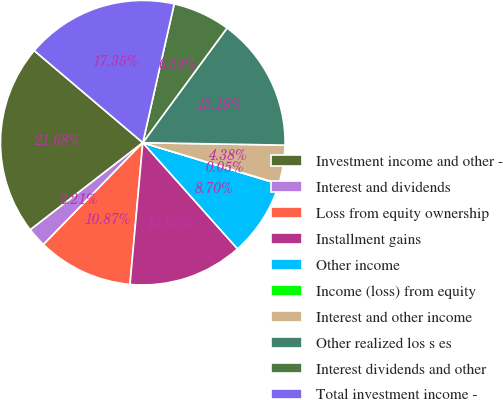<chart> <loc_0><loc_0><loc_500><loc_500><pie_chart><fcel>Investment income and other -<fcel>Interest and dividends<fcel>Loss from equity ownership<fcel>Installment gains<fcel>Other income<fcel>Income (loss) from equity<fcel>Interest and other income<fcel>Other realized los s es<fcel>Interest dividends and other<fcel>Total investment income -<nl><fcel>21.68%<fcel>2.21%<fcel>10.87%<fcel>13.03%<fcel>8.7%<fcel>0.05%<fcel>4.38%<fcel>15.19%<fcel>6.54%<fcel>17.35%<nl></chart> 